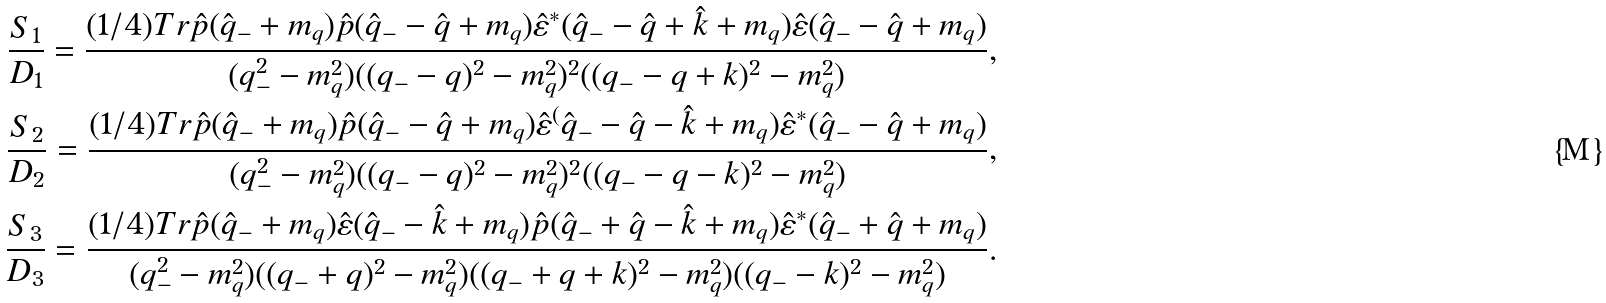<formula> <loc_0><loc_0><loc_500><loc_500>\frac { S _ { 1 } } { D _ { 1 } } = \frac { ( 1 / 4 ) T r \hat { p } ( \hat { q } _ { - } + m _ { q } ) \hat { p } ( \hat { q } _ { - } - \hat { q } + m _ { q } ) \hat { \varepsilon } ^ { * } ( \hat { q } _ { - } - \hat { q } + \hat { k } + m _ { q } ) \hat { \varepsilon } ( \hat { q } _ { - } - \hat { q } + m _ { q } ) } { ( q _ { - } ^ { 2 } - m ^ { 2 } _ { q } ) ( ( q _ { - } - q ) ^ { 2 } - m ^ { 2 } _ { q } ) ^ { 2 } ( ( q _ { - } - q + k ) ^ { 2 } - m ^ { 2 } _ { q } ) } , \\ \frac { S _ { 2 } } { D _ { 2 } } = \frac { ( 1 / 4 ) T r \hat { p } ( \hat { q } _ { - } + m _ { q } ) \hat { p } ( \hat { q } _ { - } - \hat { q } + m _ { q } ) \hat { \varepsilon } ^ { ( } \hat { q } _ { - } - \hat { q } - \hat { k } + m _ { q } ) \hat { \varepsilon } ^ { * } ( \hat { q } _ { - } - \hat { q } + m _ { q } ) } { ( q _ { - } ^ { 2 } - m ^ { 2 } _ { q } ) ( ( q _ { - } - q ) ^ { 2 } - m ^ { 2 } _ { q } ) ^ { 2 } ( ( q _ { - } - q - k ) ^ { 2 } - m _ { q } ^ { 2 } ) } , \\ \frac { S _ { 3 } } { D _ { 3 } } = \frac { ( 1 / 4 ) T r \hat { p } ( \hat { q } _ { - } + m _ { q } ) \hat { \varepsilon } ( \hat { q } _ { - } - \hat { k } + m _ { q } ) \hat { p } ( \hat { q } _ { - } + \hat { q } - \hat { k } + m _ { q } ) \hat { \varepsilon } ^ { * } ( \hat { q } _ { - } + \hat { q } + m _ { q } ) } { ( q _ { - } ^ { 2 } - m ^ { 2 } _ { q } ) ( ( q _ { - } + q ) ^ { 2 } - m ^ { 2 } _ { q } ) ( ( q _ { - } + q + k ) ^ { 2 } - m ^ { 2 } _ { q } ) ( ( q _ { - } - k ) ^ { 2 } - m ^ { 2 } _ { q } ) } .</formula> 